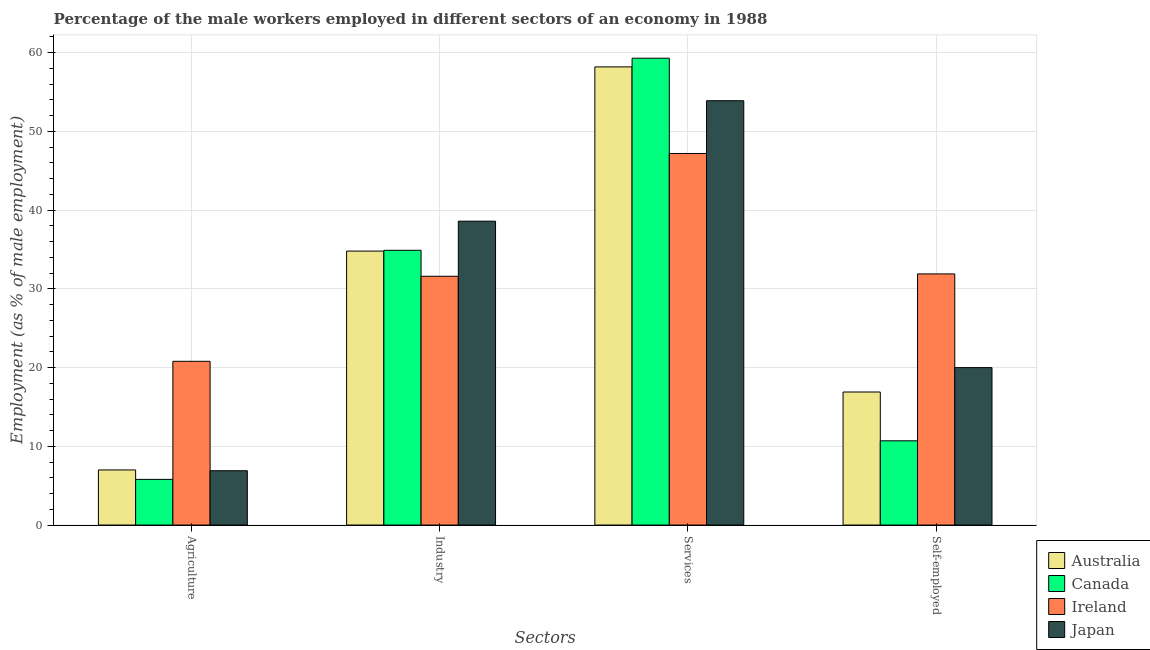How many different coloured bars are there?
Offer a very short reply. 4. How many bars are there on the 3rd tick from the left?
Provide a succinct answer. 4. How many bars are there on the 2nd tick from the right?
Keep it short and to the point. 4. What is the label of the 2nd group of bars from the left?
Ensure brevity in your answer.  Industry. Across all countries, what is the maximum percentage of self employed male workers?
Provide a short and direct response. 31.9. Across all countries, what is the minimum percentage of male workers in services?
Keep it short and to the point. 47.2. In which country was the percentage of male workers in industry maximum?
Your response must be concise. Japan. In which country was the percentage of self employed male workers minimum?
Provide a short and direct response. Canada. What is the total percentage of self employed male workers in the graph?
Ensure brevity in your answer.  79.5. What is the difference between the percentage of male workers in agriculture in Ireland and that in Australia?
Your response must be concise. 13.8. What is the difference between the percentage of male workers in agriculture in Australia and the percentage of self employed male workers in Canada?
Your answer should be very brief. -3.7. What is the average percentage of male workers in agriculture per country?
Provide a short and direct response. 10.12. What is the difference between the percentage of self employed male workers and percentage of male workers in agriculture in Australia?
Your answer should be compact. 9.9. In how many countries, is the percentage of self employed male workers greater than 32 %?
Give a very brief answer. 0. What is the ratio of the percentage of male workers in industry in Canada to that in Australia?
Offer a terse response. 1. Is the percentage of male workers in agriculture in Ireland less than that in Japan?
Give a very brief answer. No. What is the difference between the highest and the second highest percentage of male workers in services?
Offer a very short reply. 1.1. What is the difference between the highest and the lowest percentage of male workers in industry?
Keep it short and to the point. 7. Is the sum of the percentage of male workers in industry in Japan and Australia greater than the maximum percentage of self employed male workers across all countries?
Give a very brief answer. Yes. What does the 3rd bar from the left in Services represents?
Make the answer very short. Ireland. What does the 2nd bar from the right in Agriculture represents?
Provide a succinct answer. Ireland. Is it the case that in every country, the sum of the percentage of male workers in agriculture and percentage of male workers in industry is greater than the percentage of male workers in services?
Keep it short and to the point. No. Are all the bars in the graph horizontal?
Your answer should be very brief. No. How many countries are there in the graph?
Offer a very short reply. 4. Are the values on the major ticks of Y-axis written in scientific E-notation?
Ensure brevity in your answer.  No. Does the graph contain any zero values?
Ensure brevity in your answer.  No. Does the graph contain grids?
Your answer should be compact. Yes. Where does the legend appear in the graph?
Keep it short and to the point. Bottom right. What is the title of the graph?
Make the answer very short. Percentage of the male workers employed in different sectors of an economy in 1988. Does "Hungary" appear as one of the legend labels in the graph?
Your answer should be very brief. No. What is the label or title of the X-axis?
Make the answer very short. Sectors. What is the label or title of the Y-axis?
Ensure brevity in your answer.  Employment (as % of male employment). What is the Employment (as % of male employment) in Canada in Agriculture?
Keep it short and to the point. 5.8. What is the Employment (as % of male employment) of Ireland in Agriculture?
Offer a terse response. 20.8. What is the Employment (as % of male employment) in Japan in Agriculture?
Make the answer very short. 6.9. What is the Employment (as % of male employment) in Australia in Industry?
Ensure brevity in your answer.  34.8. What is the Employment (as % of male employment) of Canada in Industry?
Your response must be concise. 34.9. What is the Employment (as % of male employment) in Ireland in Industry?
Your answer should be compact. 31.6. What is the Employment (as % of male employment) of Japan in Industry?
Make the answer very short. 38.6. What is the Employment (as % of male employment) in Australia in Services?
Your response must be concise. 58.2. What is the Employment (as % of male employment) of Canada in Services?
Your answer should be very brief. 59.3. What is the Employment (as % of male employment) of Ireland in Services?
Your response must be concise. 47.2. What is the Employment (as % of male employment) of Japan in Services?
Provide a short and direct response. 53.9. What is the Employment (as % of male employment) in Australia in Self-employed?
Offer a very short reply. 16.9. What is the Employment (as % of male employment) of Canada in Self-employed?
Offer a terse response. 10.7. What is the Employment (as % of male employment) in Ireland in Self-employed?
Keep it short and to the point. 31.9. Across all Sectors, what is the maximum Employment (as % of male employment) of Australia?
Provide a succinct answer. 58.2. Across all Sectors, what is the maximum Employment (as % of male employment) of Canada?
Give a very brief answer. 59.3. Across all Sectors, what is the maximum Employment (as % of male employment) in Ireland?
Your answer should be very brief. 47.2. Across all Sectors, what is the maximum Employment (as % of male employment) in Japan?
Offer a very short reply. 53.9. Across all Sectors, what is the minimum Employment (as % of male employment) in Canada?
Make the answer very short. 5.8. Across all Sectors, what is the minimum Employment (as % of male employment) of Ireland?
Keep it short and to the point. 20.8. Across all Sectors, what is the minimum Employment (as % of male employment) of Japan?
Make the answer very short. 6.9. What is the total Employment (as % of male employment) in Australia in the graph?
Make the answer very short. 116.9. What is the total Employment (as % of male employment) in Canada in the graph?
Your answer should be compact. 110.7. What is the total Employment (as % of male employment) of Ireland in the graph?
Ensure brevity in your answer.  131.5. What is the total Employment (as % of male employment) of Japan in the graph?
Make the answer very short. 119.4. What is the difference between the Employment (as % of male employment) in Australia in Agriculture and that in Industry?
Offer a very short reply. -27.8. What is the difference between the Employment (as % of male employment) in Canada in Agriculture and that in Industry?
Your answer should be compact. -29.1. What is the difference between the Employment (as % of male employment) of Ireland in Agriculture and that in Industry?
Offer a very short reply. -10.8. What is the difference between the Employment (as % of male employment) in Japan in Agriculture and that in Industry?
Offer a terse response. -31.7. What is the difference between the Employment (as % of male employment) in Australia in Agriculture and that in Services?
Offer a terse response. -51.2. What is the difference between the Employment (as % of male employment) in Canada in Agriculture and that in Services?
Ensure brevity in your answer.  -53.5. What is the difference between the Employment (as % of male employment) of Ireland in Agriculture and that in Services?
Give a very brief answer. -26.4. What is the difference between the Employment (as % of male employment) of Japan in Agriculture and that in Services?
Ensure brevity in your answer.  -47. What is the difference between the Employment (as % of male employment) of Australia in Agriculture and that in Self-employed?
Provide a short and direct response. -9.9. What is the difference between the Employment (as % of male employment) in Australia in Industry and that in Services?
Your response must be concise. -23.4. What is the difference between the Employment (as % of male employment) of Canada in Industry and that in Services?
Offer a terse response. -24.4. What is the difference between the Employment (as % of male employment) in Ireland in Industry and that in Services?
Keep it short and to the point. -15.6. What is the difference between the Employment (as % of male employment) in Japan in Industry and that in Services?
Ensure brevity in your answer.  -15.3. What is the difference between the Employment (as % of male employment) of Canada in Industry and that in Self-employed?
Make the answer very short. 24.2. What is the difference between the Employment (as % of male employment) in Japan in Industry and that in Self-employed?
Keep it short and to the point. 18.6. What is the difference between the Employment (as % of male employment) of Australia in Services and that in Self-employed?
Provide a short and direct response. 41.3. What is the difference between the Employment (as % of male employment) in Canada in Services and that in Self-employed?
Your answer should be very brief. 48.6. What is the difference between the Employment (as % of male employment) in Ireland in Services and that in Self-employed?
Your answer should be compact. 15.3. What is the difference between the Employment (as % of male employment) of Japan in Services and that in Self-employed?
Give a very brief answer. 33.9. What is the difference between the Employment (as % of male employment) in Australia in Agriculture and the Employment (as % of male employment) in Canada in Industry?
Keep it short and to the point. -27.9. What is the difference between the Employment (as % of male employment) in Australia in Agriculture and the Employment (as % of male employment) in Ireland in Industry?
Keep it short and to the point. -24.6. What is the difference between the Employment (as % of male employment) of Australia in Agriculture and the Employment (as % of male employment) of Japan in Industry?
Offer a very short reply. -31.6. What is the difference between the Employment (as % of male employment) of Canada in Agriculture and the Employment (as % of male employment) of Ireland in Industry?
Your answer should be compact. -25.8. What is the difference between the Employment (as % of male employment) in Canada in Agriculture and the Employment (as % of male employment) in Japan in Industry?
Offer a terse response. -32.8. What is the difference between the Employment (as % of male employment) of Ireland in Agriculture and the Employment (as % of male employment) of Japan in Industry?
Offer a terse response. -17.8. What is the difference between the Employment (as % of male employment) in Australia in Agriculture and the Employment (as % of male employment) in Canada in Services?
Give a very brief answer. -52.3. What is the difference between the Employment (as % of male employment) of Australia in Agriculture and the Employment (as % of male employment) of Ireland in Services?
Offer a terse response. -40.2. What is the difference between the Employment (as % of male employment) in Australia in Agriculture and the Employment (as % of male employment) in Japan in Services?
Make the answer very short. -46.9. What is the difference between the Employment (as % of male employment) of Canada in Agriculture and the Employment (as % of male employment) of Ireland in Services?
Give a very brief answer. -41.4. What is the difference between the Employment (as % of male employment) of Canada in Agriculture and the Employment (as % of male employment) of Japan in Services?
Your response must be concise. -48.1. What is the difference between the Employment (as % of male employment) of Ireland in Agriculture and the Employment (as % of male employment) of Japan in Services?
Offer a terse response. -33.1. What is the difference between the Employment (as % of male employment) of Australia in Agriculture and the Employment (as % of male employment) of Ireland in Self-employed?
Offer a terse response. -24.9. What is the difference between the Employment (as % of male employment) of Canada in Agriculture and the Employment (as % of male employment) of Ireland in Self-employed?
Your answer should be very brief. -26.1. What is the difference between the Employment (as % of male employment) in Canada in Agriculture and the Employment (as % of male employment) in Japan in Self-employed?
Provide a succinct answer. -14.2. What is the difference between the Employment (as % of male employment) of Australia in Industry and the Employment (as % of male employment) of Canada in Services?
Offer a very short reply. -24.5. What is the difference between the Employment (as % of male employment) of Australia in Industry and the Employment (as % of male employment) of Japan in Services?
Offer a terse response. -19.1. What is the difference between the Employment (as % of male employment) of Canada in Industry and the Employment (as % of male employment) of Japan in Services?
Provide a succinct answer. -19. What is the difference between the Employment (as % of male employment) in Ireland in Industry and the Employment (as % of male employment) in Japan in Services?
Ensure brevity in your answer.  -22.3. What is the difference between the Employment (as % of male employment) in Australia in Industry and the Employment (as % of male employment) in Canada in Self-employed?
Give a very brief answer. 24.1. What is the difference between the Employment (as % of male employment) of Australia in Industry and the Employment (as % of male employment) of Ireland in Self-employed?
Give a very brief answer. 2.9. What is the difference between the Employment (as % of male employment) in Australia in Industry and the Employment (as % of male employment) in Japan in Self-employed?
Give a very brief answer. 14.8. What is the difference between the Employment (as % of male employment) of Canada in Industry and the Employment (as % of male employment) of Ireland in Self-employed?
Your answer should be compact. 3. What is the difference between the Employment (as % of male employment) in Ireland in Industry and the Employment (as % of male employment) in Japan in Self-employed?
Give a very brief answer. 11.6. What is the difference between the Employment (as % of male employment) of Australia in Services and the Employment (as % of male employment) of Canada in Self-employed?
Keep it short and to the point. 47.5. What is the difference between the Employment (as % of male employment) in Australia in Services and the Employment (as % of male employment) in Ireland in Self-employed?
Make the answer very short. 26.3. What is the difference between the Employment (as % of male employment) of Australia in Services and the Employment (as % of male employment) of Japan in Self-employed?
Your answer should be compact. 38.2. What is the difference between the Employment (as % of male employment) in Canada in Services and the Employment (as % of male employment) in Ireland in Self-employed?
Provide a succinct answer. 27.4. What is the difference between the Employment (as % of male employment) of Canada in Services and the Employment (as % of male employment) of Japan in Self-employed?
Offer a very short reply. 39.3. What is the difference between the Employment (as % of male employment) of Ireland in Services and the Employment (as % of male employment) of Japan in Self-employed?
Your response must be concise. 27.2. What is the average Employment (as % of male employment) of Australia per Sectors?
Give a very brief answer. 29.23. What is the average Employment (as % of male employment) in Canada per Sectors?
Your answer should be compact. 27.68. What is the average Employment (as % of male employment) of Ireland per Sectors?
Ensure brevity in your answer.  32.88. What is the average Employment (as % of male employment) of Japan per Sectors?
Make the answer very short. 29.85. What is the difference between the Employment (as % of male employment) of Australia and Employment (as % of male employment) of Canada in Agriculture?
Give a very brief answer. 1.2. What is the difference between the Employment (as % of male employment) in Australia and Employment (as % of male employment) in Japan in Agriculture?
Keep it short and to the point. 0.1. What is the difference between the Employment (as % of male employment) in Canada and Employment (as % of male employment) in Japan in Agriculture?
Offer a terse response. -1.1. What is the difference between the Employment (as % of male employment) of Ireland and Employment (as % of male employment) of Japan in Agriculture?
Offer a terse response. 13.9. What is the difference between the Employment (as % of male employment) in Australia and Employment (as % of male employment) in Ireland in Industry?
Your response must be concise. 3.2. What is the difference between the Employment (as % of male employment) in Canada and Employment (as % of male employment) in Ireland in Industry?
Your response must be concise. 3.3. What is the difference between the Employment (as % of male employment) of Australia and Employment (as % of male employment) of Ireland in Services?
Ensure brevity in your answer.  11. What is the difference between the Employment (as % of male employment) in Australia and Employment (as % of male employment) in Japan in Services?
Keep it short and to the point. 4.3. What is the difference between the Employment (as % of male employment) in Canada and Employment (as % of male employment) in Japan in Services?
Offer a very short reply. 5.4. What is the difference between the Employment (as % of male employment) in Australia and Employment (as % of male employment) in Canada in Self-employed?
Provide a short and direct response. 6.2. What is the difference between the Employment (as % of male employment) of Australia and Employment (as % of male employment) of Ireland in Self-employed?
Keep it short and to the point. -15. What is the difference between the Employment (as % of male employment) of Canada and Employment (as % of male employment) of Ireland in Self-employed?
Provide a succinct answer. -21.2. What is the difference between the Employment (as % of male employment) of Canada and Employment (as % of male employment) of Japan in Self-employed?
Provide a short and direct response. -9.3. What is the ratio of the Employment (as % of male employment) of Australia in Agriculture to that in Industry?
Your response must be concise. 0.2. What is the ratio of the Employment (as % of male employment) in Canada in Agriculture to that in Industry?
Keep it short and to the point. 0.17. What is the ratio of the Employment (as % of male employment) of Ireland in Agriculture to that in Industry?
Your answer should be very brief. 0.66. What is the ratio of the Employment (as % of male employment) in Japan in Agriculture to that in Industry?
Your response must be concise. 0.18. What is the ratio of the Employment (as % of male employment) of Australia in Agriculture to that in Services?
Keep it short and to the point. 0.12. What is the ratio of the Employment (as % of male employment) of Canada in Agriculture to that in Services?
Your answer should be compact. 0.1. What is the ratio of the Employment (as % of male employment) of Ireland in Agriculture to that in Services?
Give a very brief answer. 0.44. What is the ratio of the Employment (as % of male employment) of Japan in Agriculture to that in Services?
Ensure brevity in your answer.  0.13. What is the ratio of the Employment (as % of male employment) of Australia in Agriculture to that in Self-employed?
Keep it short and to the point. 0.41. What is the ratio of the Employment (as % of male employment) of Canada in Agriculture to that in Self-employed?
Make the answer very short. 0.54. What is the ratio of the Employment (as % of male employment) of Ireland in Agriculture to that in Self-employed?
Make the answer very short. 0.65. What is the ratio of the Employment (as % of male employment) of Japan in Agriculture to that in Self-employed?
Your answer should be very brief. 0.34. What is the ratio of the Employment (as % of male employment) in Australia in Industry to that in Services?
Offer a terse response. 0.6. What is the ratio of the Employment (as % of male employment) in Canada in Industry to that in Services?
Your answer should be very brief. 0.59. What is the ratio of the Employment (as % of male employment) in Ireland in Industry to that in Services?
Your answer should be compact. 0.67. What is the ratio of the Employment (as % of male employment) in Japan in Industry to that in Services?
Ensure brevity in your answer.  0.72. What is the ratio of the Employment (as % of male employment) of Australia in Industry to that in Self-employed?
Offer a very short reply. 2.06. What is the ratio of the Employment (as % of male employment) in Canada in Industry to that in Self-employed?
Offer a very short reply. 3.26. What is the ratio of the Employment (as % of male employment) in Ireland in Industry to that in Self-employed?
Provide a short and direct response. 0.99. What is the ratio of the Employment (as % of male employment) of Japan in Industry to that in Self-employed?
Give a very brief answer. 1.93. What is the ratio of the Employment (as % of male employment) of Australia in Services to that in Self-employed?
Offer a terse response. 3.44. What is the ratio of the Employment (as % of male employment) of Canada in Services to that in Self-employed?
Give a very brief answer. 5.54. What is the ratio of the Employment (as % of male employment) in Ireland in Services to that in Self-employed?
Offer a terse response. 1.48. What is the ratio of the Employment (as % of male employment) in Japan in Services to that in Self-employed?
Provide a succinct answer. 2.69. What is the difference between the highest and the second highest Employment (as % of male employment) in Australia?
Provide a succinct answer. 23.4. What is the difference between the highest and the second highest Employment (as % of male employment) in Canada?
Offer a very short reply. 24.4. What is the difference between the highest and the lowest Employment (as % of male employment) in Australia?
Make the answer very short. 51.2. What is the difference between the highest and the lowest Employment (as % of male employment) in Canada?
Offer a terse response. 53.5. What is the difference between the highest and the lowest Employment (as % of male employment) in Ireland?
Ensure brevity in your answer.  26.4. 